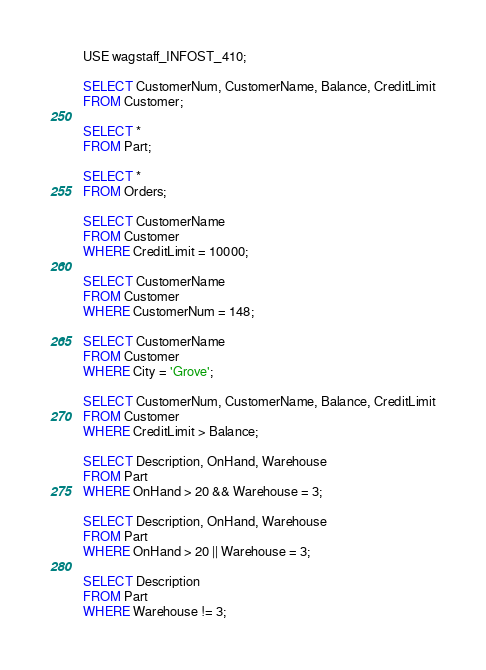Convert code to text. <code><loc_0><loc_0><loc_500><loc_500><_SQL_>USE wagstaff_INFOST_410;

SELECT CustomerNum, CustomerName, Balance, CreditLimit
FROM Customer;

SELECT * 
FROM Part;

SELECT * 
FROM Orders;

SELECT CustomerName 
FROM Customer
WHERE CreditLimit = 10000;

SELECT CustomerName
FROM Customer
WHERE CustomerNum = 148;

SELECT CustomerName
FROM Customer
WHERE City = 'Grove';

SELECT CustomerNum, CustomerName, Balance, CreditLimit
FROM Customer
WHERE CreditLimit > Balance;

SELECT Description, OnHand, Warehouse
FROM Part
WHERE OnHand > 20 && Warehouse = 3;

SELECT Description, OnHand, Warehouse
FROM Part
WHERE OnHand > 20 || Warehouse = 3;

SELECT Description
FROM Part
WHERE Warehouse != 3;</code> 